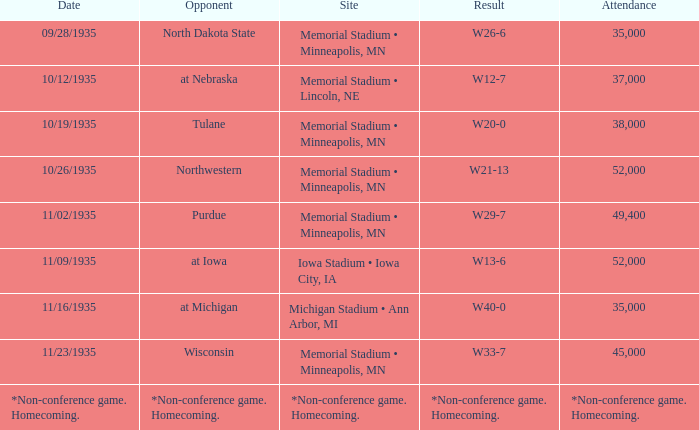Who was the opponent against which the result was w20-0? Tulane. 